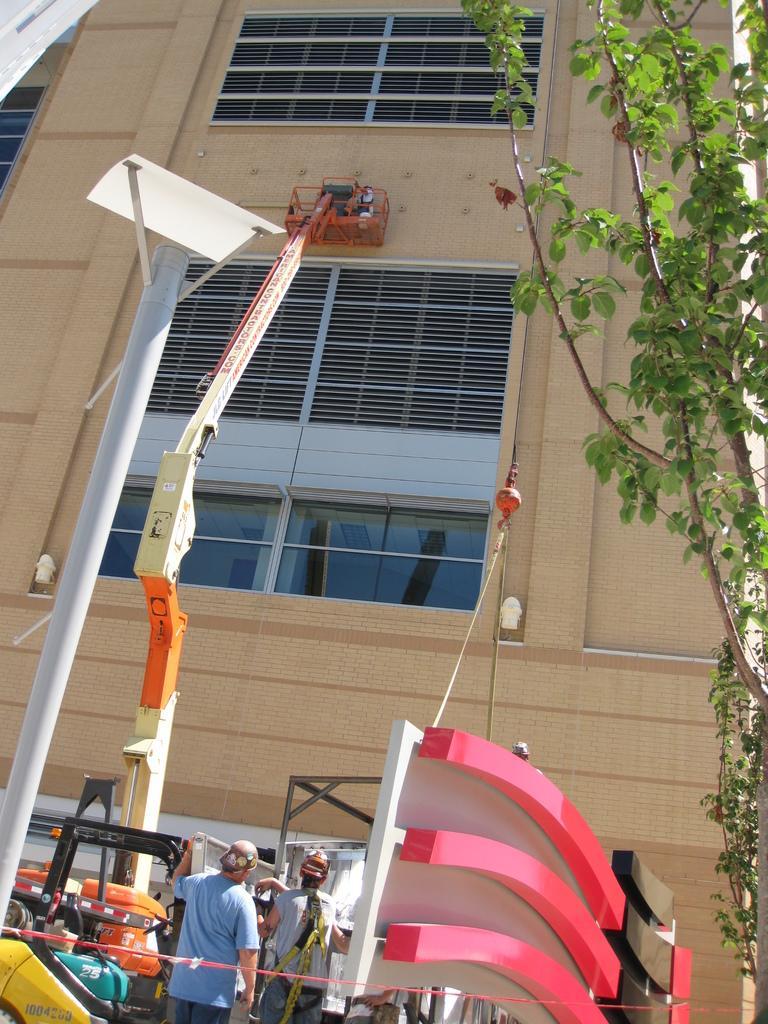How would you summarize this image in a sentence or two? In this picture we can see there are two people standing on the path and on the right side of the people there is an object and a tree. On the left side of the people there is a pole and a person is sitting on a fire engine ladder. In front of the people there is a building with windows. 